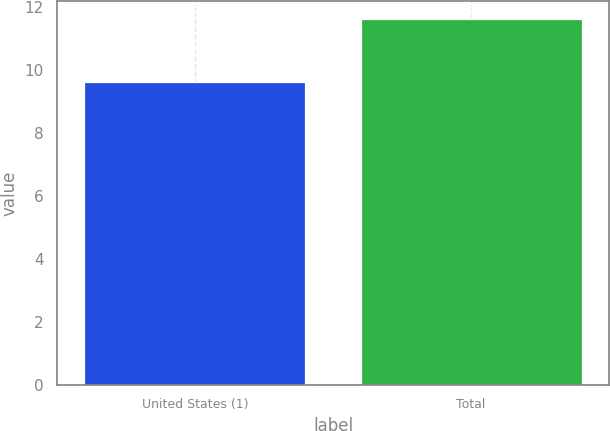Convert chart. <chart><loc_0><loc_0><loc_500><loc_500><bar_chart><fcel>United States (1)<fcel>Total<nl><fcel>9.6<fcel>11.6<nl></chart> 